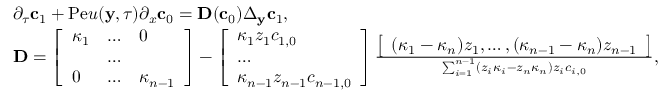<formula> <loc_0><loc_0><loc_500><loc_500>\begin{array} { r l } & { \partial _ { \tau } c _ { 1 } + P e u ( y , \tau ) \partial _ { x } c _ { 0 } = D ( c _ { 0 } ) \Delta _ { y } c _ { 1 } , } \\ & { D = \left [ \begin{array} { l l l } { \kappa _ { 1 } } & { \hdots } & { 0 } \\ & { \hdots } & \\ { 0 } & { \hdots } & { \kappa _ { n - 1 } } \end{array} \right ] - \left [ \begin{array} { l } { \kappa _ { 1 } z _ { 1 } c _ { 1 , 0 } } \\ { \hdots } \\ { \kappa _ { n - 1 } z _ { n - 1 } c _ { n - 1 , 0 } } \end{array} \right ] \frac { \left [ \begin{array} { l } { ( \kappa _ { 1 } - \kappa _ { n } ) z _ { 1 } , \hdots , ( \kappa _ { n - 1 } - \kappa _ { n } ) z _ { n - 1 } } \end{array} \right ] } { \sum _ { i = 1 } ^ { n - 1 } ( z _ { i } \kappa _ { i } - z _ { n } \kappa _ { n } ) z _ { i } c _ { i , 0 } } , } \end{array}</formula> 